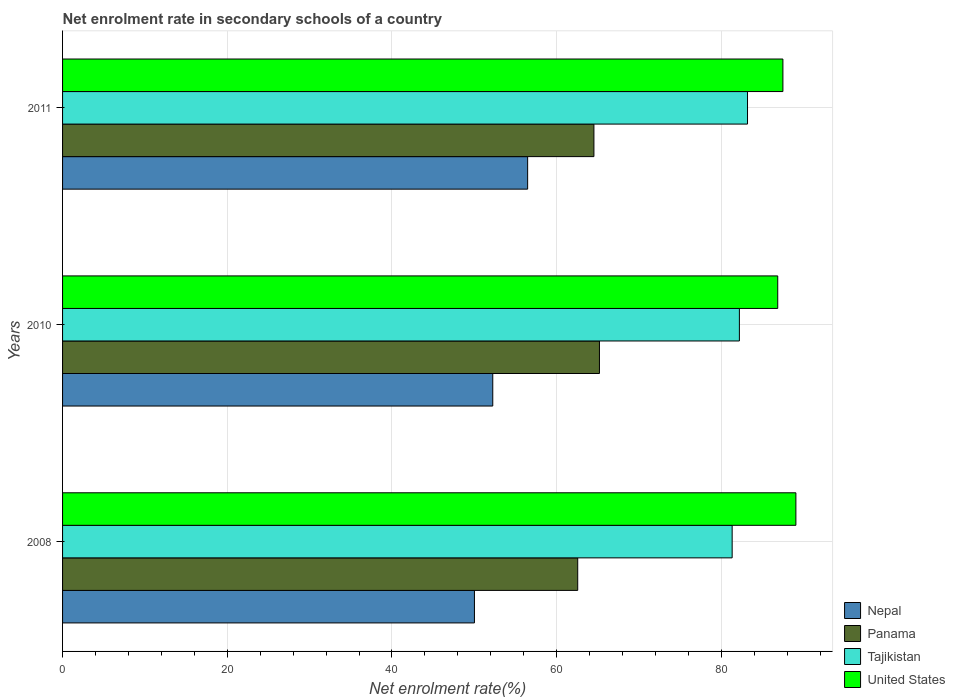How many groups of bars are there?
Ensure brevity in your answer.  3. Are the number of bars per tick equal to the number of legend labels?
Provide a succinct answer. Yes. Are the number of bars on each tick of the Y-axis equal?
Offer a terse response. Yes. How many bars are there on the 2nd tick from the top?
Give a very brief answer. 4. What is the label of the 1st group of bars from the top?
Give a very brief answer. 2011. What is the net enrolment rate in secondary schools in Tajikistan in 2011?
Give a very brief answer. 83.17. Across all years, what is the maximum net enrolment rate in secondary schools in Tajikistan?
Your response must be concise. 83.17. Across all years, what is the minimum net enrolment rate in secondary schools in Nepal?
Offer a terse response. 50.01. What is the total net enrolment rate in secondary schools in Nepal in the graph?
Provide a succinct answer. 158.72. What is the difference between the net enrolment rate in secondary schools in United States in 2010 and that in 2011?
Ensure brevity in your answer.  -0.63. What is the difference between the net enrolment rate in secondary schools in United States in 2010 and the net enrolment rate in secondary schools in Panama in 2008?
Your answer should be compact. 24.29. What is the average net enrolment rate in secondary schools in Tajikistan per year?
Offer a very short reply. 82.22. In the year 2010, what is the difference between the net enrolment rate in secondary schools in United States and net enrolment rate in secondary schools in Panama?
Your answer should be very brief. 21.65. In how many years, is the net enrolment rate in secondary schools in Nepal greater than 20 %?
Provide a short and direct response. 3. What is the ratio of the net enrolment rate in secondary schools in Tajikistan in 2008 to that in 2011?
Your answer should be compact. 0.98. Is the difference between the net enrolment rate in secondary schools in United States in 2010 and 2011 greater than the difference between the net enrolment rate in secondary schools in Panama in 2010 and 2011?
Your answer should be very brief. No. What is the difference between the highest and the second highest net enrolment rate in secondary schools in Panama?
Provide a short and direct response. 0.67. What is the difference between the highest and the lowest net enrolment rate in secondary schools in United States?
Offer a very short reply. 2.2. Is it the case that in every year, the sum of the net enrolment rate in secondary schools in Tajikistan and net enrolment rate in secondary schools in Panama is greater than the sum of net enrolment rate in secondary schools in Nepal and net enrolment rate in secondary schools in United States?
Keep it short and to the point. Yes. What does the 3rd bar from the top in 2008 represents?
Give a very brief answer. Panama. What does the 1st bar from the bottom in 2011 represents?
Keep it short and to the point. Nepal. Are all the bars in the graph horizontal?
Keep it short and to the point. Yes. How many years are there in the graph?
Your response must be concise. 3. Are the values on the major ticks of X-axis written in scientific E-notation?
Your response must be concise. No. Where does the legend appear in the graph?
Offer a terse response. Bottom right. How many legend labels are there?
Your response must be concise. 4. What is the title of the graph?
Ensure brevity in your answer.  Net enrolment rate in secondary schools of a country. What is the label or title of the X-axis?
Your answer should be very brief. Net enrolment rate(%). What is the Net enrolment rate(%) of Nepal in 2008?
Provide a succinct answer. 50.01. What is the Net enrolment rate(%) of Panama in 2008?
Offer a terse response. 62.55. What is the Net enrolment rate(%) in Tajikistan in 2008?
Give a very brief answer. 81.31. What is the Net enrolment rate(%) of United States in 2008?
Your answer should be very brief. 89.04. What is the Net enrolment rate(%) of Nepal in 2010?
Give a very brief answer. 52.24. What is the Net enrolment rate(%) of Panama in 2010?
Offer a terse response. 65.19. What is the Net enrolment rate(%) of Tajikistan in 2010?
Keep it short and to the point. 82.18. What is the Net enrolment rate(%) in United States in 2010?
Keep it short and to the point. 86.84. What is the Net enrolment rate(%) of Nepal in 2011?
Provide a succinct answer. 56.47. What is the Net enrolment rate(%) of Panama in 2011?
Give a very brief answer. 64.52. What is the Net enrolment rate(%) in Tajikistan in 2011?
Provide a short and direct response. 83.17. What is the Net enrolment rate(%) of United States in 2011?
Your response must be concise. 87.47. Across all years, what is the maximum Net enrolment rate(%) of Nepal?
Your response must be concise. 56.47. Across all years, what is the maximum Net enrolment rate(%) of Panama?
Provide a succinct answer. 65.19. Across all years, what is the maximum Net enrolment rate(%) of Tajikistan?
Provide a short and direct response. 83.17. Across all years, what is the maximum Net enrolment rate(%) of United States?
Make the answer very short. 89.04. Across all years, what is the minimum Net enrolment rate(%) of Nepal?
Make the answer very short. 50.01. Across all years, what is the minimum Net enrolment rate(%) in Panama?
Offer a terse response. 62.55. Across all years, what is the minimum Net enrolment rate(%) in Tajikistan?
Offer a very short reply. 81.31. Across all years, what is the minimum Net enrolment rate(%) in United States?
Offer a terse response. 86.84. What is the total Net enrolment rate(%) of Nepal in the graph?
Ensure brevity in your answer.  158.72. What is the total Net enrolment rate(%) in Panama in the graph?
Keep it short and to the point. 192.27. What is the total Net enrolment rate(%) in Tajikistan in the graph?
Provide a short and direct response. 246.66. What is the total Net enrolment rate(%) of United States in the graph?
Provide a short and direct response. 263.35. What is the difference between the Net enrolment rate(%) in Nepal in 2008 and that in 2010?
Ensure brevity in your answer.  -2.23. What is the difference between the Net enrolment rate(%) in Panama in 2008 and that in 2010?
Keep it short and to the point. -2.64. What is the difference between the Net enrolment rate(%) of Tajikistan in 2008 and that in 2010?
Your answer should be compact. -0.88. What is the difference between the Net enrolment rate(%) of United States in 2008 and that in 2010?
Your answer should be very brief. 2.2. What is the difference between the Net enrolment rate(%) in Nepal in 2008 and that in 2011?
Provide a short and direct response. -6.46. What is the difference between the Net enrolment rate(%) of Panama in 2008 and that in 2011?
Keep it short and to the point. -1.97. What is the difference between the Net enrolment rate(%) in Tajikistan in 2008 and that in 2011?
Keep it short and to the point. -1.86. What is the difference between the Net enrolment rate(%) in United States in 2008 and that in 2011?
Make the answer very short. 1.58. What is the difference between the Net enrolment rate(%) in Nepal in 2010 and that in 2011?
Give a very brief answer. -4.23. What is the difference between the Net enrolment rate(%) in Panama in 2010 and that in 2011?
Your response must be concise. 0.67. What is the difference between the Net enrolment rate(%) in Tajikistan in 2010 and that in 2011?
Your answer should be very brief. -0.99. What is the difference between the Net enrolment rate(%) of United States in 2010 and that in 2011?
Offer a terse response. -0.63. What is the difference between the Net enrolment rate(%) in Nepal in 2008 and the Net enrolment rate(%) in Panama in 2010?
Your response must be concise. -15.18. What is the difference between the Net enrolment rate(%) of Nepal in 2008 and the Net enrolment rate(%) of Tajikistan in 2010?
Your response must be concise. -32.17. What is the difference between the Net enrolment rate(%) of Nepal in 2008 and the Net enrolment rate(%) of United States in 2010?
Your answer should be very brief. -36.83. What is the difference between the Net enrolment rate(%) in Panama in 2008 and the Net enrolment rate(%) in Tajikistan in 2010?
Offer a very short reply. -19.63. What is the difference between the Net enrolment rate(%) in Panama in 2008 and the Net enrolment rate(%) in United States in 2010?
Give a very brief answer. -24.29. What is the difference between the Net enrolment rate(%) of Tajikistan in 2008 and the Net enrolment rate(%) of United States in 2010?
Offer a terse response. -5.53. What is the difference between the Net enrolment rate(%) of Nepal in 2008 and the Net enrolment rate(%) of Panama in 2011?
Offer a terse response. -14.51. What is the difference between the Net enrolment rate(%) of Nepal in 2008 and the Net enrolment rate(%) of Tajikistan in 2011?
Your answer should be compact. -33.16. What is the difference between the Net enrolment rate(%) in Nepal in 2008 and the Net enrolment rate(%) in United States in 2011?
Provide a succinct answer. -37.46. What is the difference between the Net enrolment rate(%) in Panama in 2008 and the Net enrolment rate(%) in Tajikistan in 2011?
Provide a short and direct response. -20.62. What is the difference between the Net enrolment rate(%) in Panama in 2008 and the Net enrolment rate(%) in United States in 2011?
Offer a very short reply. -24.92. What is the difference between the Net enrolment rate(%) in Tajikistan in 2008 and the Net enrolment rate(%) in United States in 2011?
Provide a succinct answer. -6.16. What is the difference between the Net enrolment rate(%) in Nepal in 2010 and the Net enrolment rate(%) in Panama in 2011?
Your answer should be compact. -12.28. What is the difference between the Net enrolment rate(%) of Nepal in 2010 and the Net enrolment rate(%) of Tajikistan in 2011?
Your response must be concise. -30.93. What is the difference between the Net enrolment rate(%) of Nepal in 2010 and the Net enrolment rate(%) of United States in 2011?
Your response must be concise. -35.23. What is the difference between the Net enrolment rate(%) of Panama in 2010 and the Net enrolment rate(%) of Tajikistan in 2011?
Give a very brief answer. -17.98. What is the difference between the Net enrolment rate(%) in Panama in 2010 and the Net enrolment rate(%) in United States in 2011?
Make the answer very short. -22.28. What is the difference between the Net enrolment rate(%) of Tajikistan in 2010 and the Net enrolment rate(%) of United States in 2011?
Offer a very short reply. -5.28. What is the average Net enrolment rate(%) in Nepal per year?
Keep it short and to the point. 52.91. What is the average Net enrolment rate(%) of Panama per year?
Your response must be concise. 64.09. What is the average Net enrolment rate(%) of Tajikistan per year?
Provide a succinct answer. 82.22. What is the average Net enrolment rate(%) of United States per year?
Keep it short and to the point. 87.78. In the year 2008, what is the difference between the Net enrolment rate(%) of Nepal and Net enrolment rate(%) of Panama?
Give a very brief answer. -12.54. In the year 2008, what is the difference between the Net enrolment rate(%) of Nepal and Net enrolment rate(%) of Tajikistan?
Keep it short and to the point. -31.29. In the year 2008, what is the difference between the Net enrolment rate(%) of Nepal and Net enrolment rate(%) of United States?
Provide a short and direct response. -39.03. In the year 2008, what is the difference between the Net enrolment rate(%) of Panama and Net enrolment rate(%) of Tajikistan?
Keep it short and to the point. -18.75. In the year 2008, what is the difference between the Net enrolment rate(%) in Panama and Net enrolment rate(%) in United States?
Make the answer very short. -26.49. In the year 2008, what is the difference between the Net enrolment rate(%) of Tajikistan and Net enrolment rate(%) of United States?
Give a very brief answer. -7.74. In the year 2010, what is the difference between the Net enrolment rate(%) in Nepal and Net enrolment rate(%) in Panama?
Ensure brevity in your answer.  -12.95. In the year 2010, what is the difference between the Net enrolment rate(%) in Nepal and Net enrolment rate(%) in Tajikistan?
Make the answer very short. -29.95. In the year 2010, what is the difference between the Net enrolment rate(%) of Nepal and Net enrolment rate(%) of United States?
Your answer should be very brief. -34.6. In the year 2010, what is the difference between the Net enrolment rate(%) in Panama and Net enrolment rate(%) in Tajikistan?
Provide a short and direct response. -16.99. In the year 2010, what is the difference between the Net enrolment rate(%) of Panama and Net enrolment rate(%) of United States?
Your response must be concise. -21.65. In the year 2010, what is the difference between the Net enrolment rate(%) in Tajikistan and Net enrolment rate(%) in United States?
Ensure brevity in your answer.  -4.66. In the year 2011, what is the difference between the Net enrolment rate(%) of Nepal and Net enrolment rate(%) of Panama?
Your answer should be very brief. -8.05. In the year 2011, what is the difference between the Net enrolment rate(%) in Nepal and Net enrolment rate(%) in Tajikistan?
Provide a succinct answer. -26.7. In the year 2011, what is the difference between the Net enrolment rate(%) of Nepal and Net enrolment rate(%) of United States?
Keep it short and to the point. -31. In the year 2011, what is the difference between the Net enrolment rate(%) of Panama and Net enrolment rate(%) of Tajikistan?
Ensure brevity in your answer.  -18.65. In the year 2011, what is the difference between the Net enrolment rate(%) in Panama and Net enrolment rate(%) in United States?
Offer a terse response. -22.95. In the year 2011, what is the difference between the Net enrolment rate(%) of Tajikistan and Net enrolment rate(%) of United States?
Ensure brevity in your answer.  -4.3. What is the ratio of the Net enrolment rate(%) of Nepal in 2008 to that in 2010?
Your response must be concise. 0.96. What is the ratio of the Net enrolment rate(%) in Panama in 2008 to that in 2010?
Provide a succinct answer. 0.96. What is the ratio of the Net enrolment rate(%) in Tajikistan in 2008 to that in 2010?
Keep it short and to the point. 0.99. What is the ratio of the Net enrolment rate(%) of United States in 2008 to that in 2010?
Give a very brief answer. 1.03. What is the ratio of the Net enrolment rate(%) of Nepal in 2008 to that in 2011?
Ensure brevity in your answer.  0.89. What is the ratio of the Net enrolment rate(%) of Panama in 2008 to that in 2011?
Provide a succinct answer. 0.97. What is the ratio of the Net enrolment rate(%) of Tajikistan in 2008 to that in 2011?
Make the answer very short. 0.98. What is the ratio of the Net enrolment rate(%) in United States in 2008 to that in 2011?
Your response must be concise. 1.02. What is the ratio of the Net enrolment rate(%) of Nepal in 2010 to that in 2011?
Keep it short and to the point. 0.93. What is the ratio of the Net enrolment rate(%) of Panama in 2010 to that in 2011?
Your response must be concise. 1.01. What is the difference between the highest and the second highest Net enrolment rate(%) of Nepal?
Your answer should be compact. 4.23. What is the difference between the highest and the second highest Net enrolment rate(%) of Panama?
Provide a succinct answer. 0.67. What is the difference between the highest and the second highest Net enrolment rate(%) in Tajikistan?
Your answer should be compact. 0.99. What is the difference between the highest and the second highest Net enrolment rate(%) of United States?
Offer a terse response. 1.58. What is the difference between the highest and the lowest Net enrolment rate(%) in Nepal?
Give a very brief answer. 6.46. What is the difference between the highest and the lowest Net enrolment rate(%) in Panama?
Your answer should be very brief. 2.64. What is the difference between the highest and the lowest Net enrolment rate(%) in Tajikistan?
Give a very brief answer. 1.86. What is the difference between the highest and the lowest Net enrolment rate(%) in United States?
Make the answer very short. 2.2. 